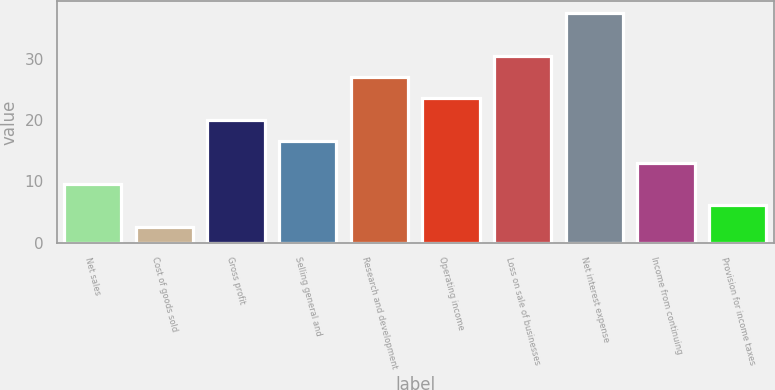Convert chart. <chart><loc_0><loc_0><loc_500><loc_500><bar_chart><fcel>Net sales<fcel>Cost of goods sold<fcel>Gross profit<fcel>Selling general and<fcel>Research and development<fcel>Operating income<fcel>Loss on sale of businesses<fcel>Net interest expense<fcel>Income from continuing<fcel>Provision for income taxes<nl><fcel>9.58<fcel>2.6<fcel>20.05<fcel>16.56<fcel>27.03<fcel>23.54<fcel>30.52<fcel>37.5<fcel>13.07<fcel>6.09<nl></chart> 